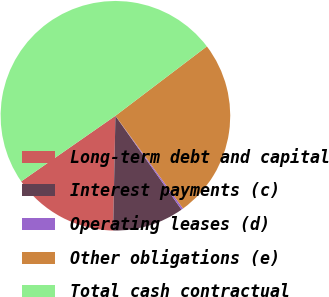Convert chart. <chart><loc_0><loc_0><loc_500><loc_500><pie_chart><fcel>Long-term debt and capital<fcel>Interest payments (c)<fcel>Operating leases (d)<fcel>Other obligations (e)<fcel>Total cash contractual<nl><fcel>15.0%<fcel>10.09%<fcel>0.26%<fcel>25.3%<fcel>49.35%<nl></chart> 